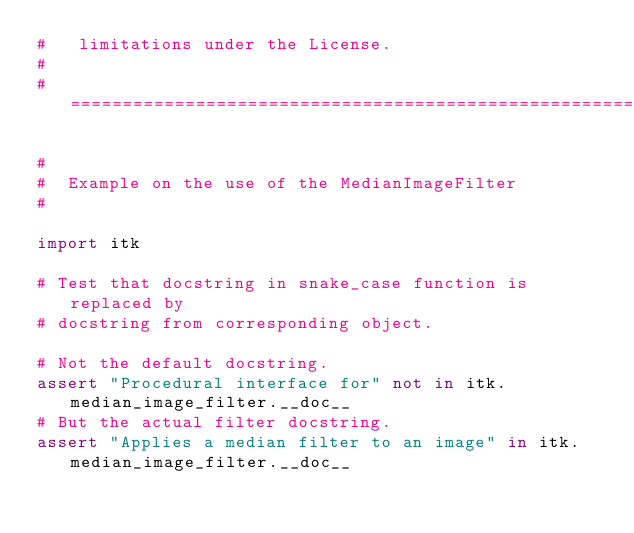Convert code to text. <code><loc_0><loc_0><loc_500><loc_500><_Python_>#   limitations under the License.
#
#==========================================================================*/

#
#  Example on the use of the MedianImageFilter
#

import itk

# Test that docstring in snake_case function is replaced by
# docstring from corresponding object.

# Not the default docstring.
assert "Procedural interface for" not in itk.median_image_filter.__doc__
# But the actual filter docstring.
assert "Applies a median filter to an image" in itk.median_image_filter.__doc__
</code> 